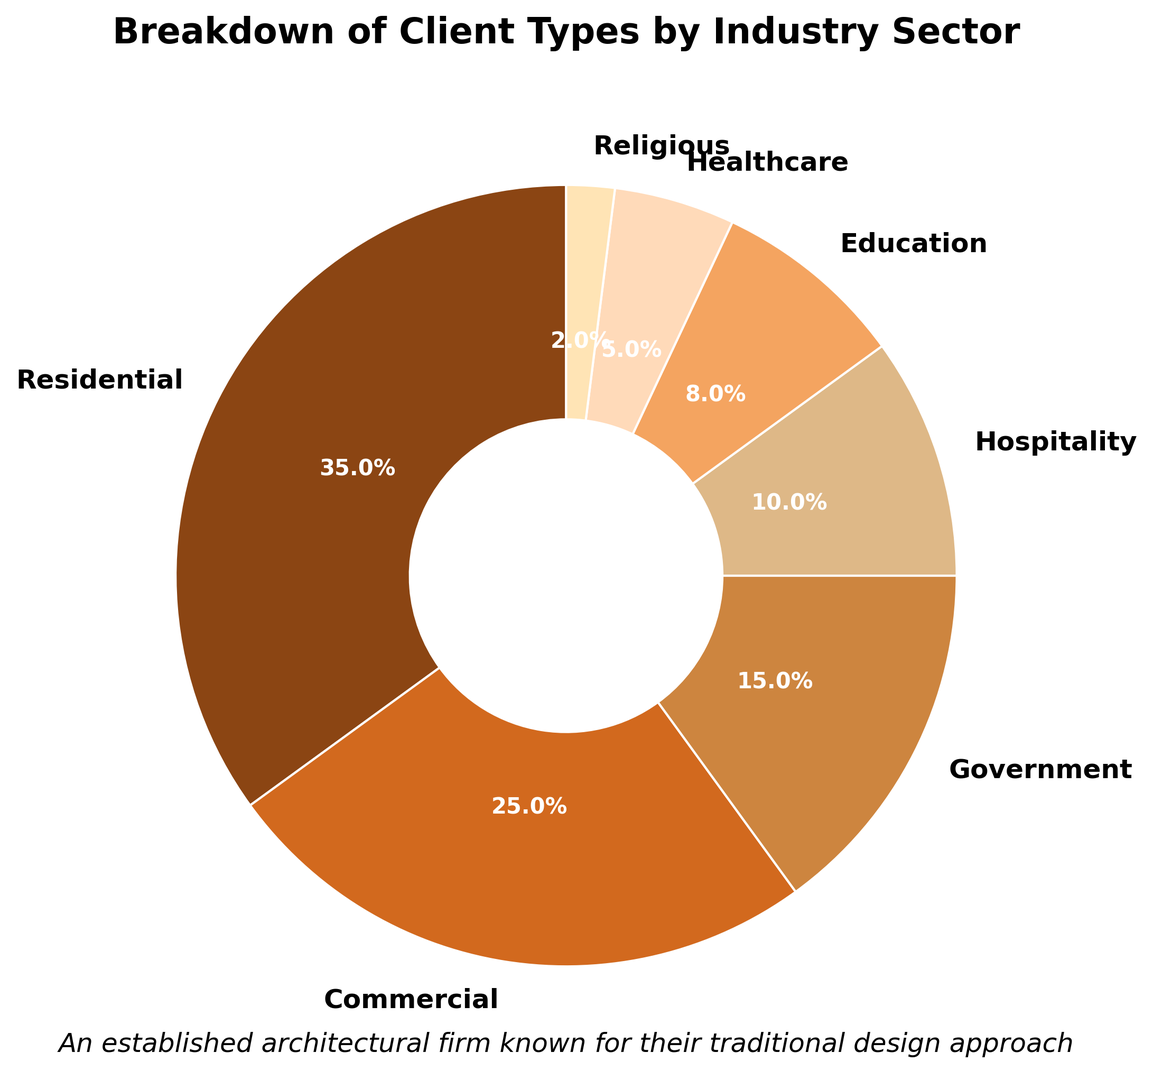Which industry sector comprises the largest percentage of clients? By referring to the figure, we can see that the 'Residential' sector occupies the largest portion of the pie chart, indicated by its size.
Answer: Residential Which industry sector comprises the smallest percentage of clients? By observing the pie chart, the 'Religious' sector occupies the smallest portion of the pie chart.
Answer: Religious How much more percentage does the Residential sector hold compared to the Healthcare sector? The Residential sector holds 35%, and the Healthcare sector holds 5%. The difference is 35% - 5% = 30%.
Answer: 30% What's the combined percentage of the Hospitality and Education sectors? The Hospitality sector holds 10%, and the Education sector holds 8%. The combined percentage is 10% + 8% = 18%.
Answer: 18% Which sector is visually represented by the darkest color? By looking at the pie chart, the darkest colored segment corresponds to the 'Residential' sector.
Answer: Residential If you add the percentages for the Government, Healthcare, and Religious sectors, what total do you get? The Government sector holds 15%, Healthcare sector holds 5%, and Religious sector holds 2%. The total is 15% + 5% + 2% = 22%.
Answer: 22% Is the percentage of Commercial clients greater or less than twice the percentage of Healthcare clients? The percentage of Commercial clients is 25%, and twice the percentage of Healthcare clients is 2 * 5% = 10%. Hence, 25% is greater than 10%.
Answer: Greater What is the difference in percentages between the Commercial and Government sectors? The Commercial sector holds 25%, and the Government sector holds 15%. The difference is 25% - 15% = 10%.
Answer: 10% What percentage of clients belong to sectors other than Residential, Commercial, and Government? The Residential sector holds 35%, the Commercial sector holds 25%, and the Government sector holds 15%. The sum for these three is 35% + 25% + 15% = 75%. Thus, the percentage of clients in other sectors is 100% - 75% = 25%.
Answer: 25% 